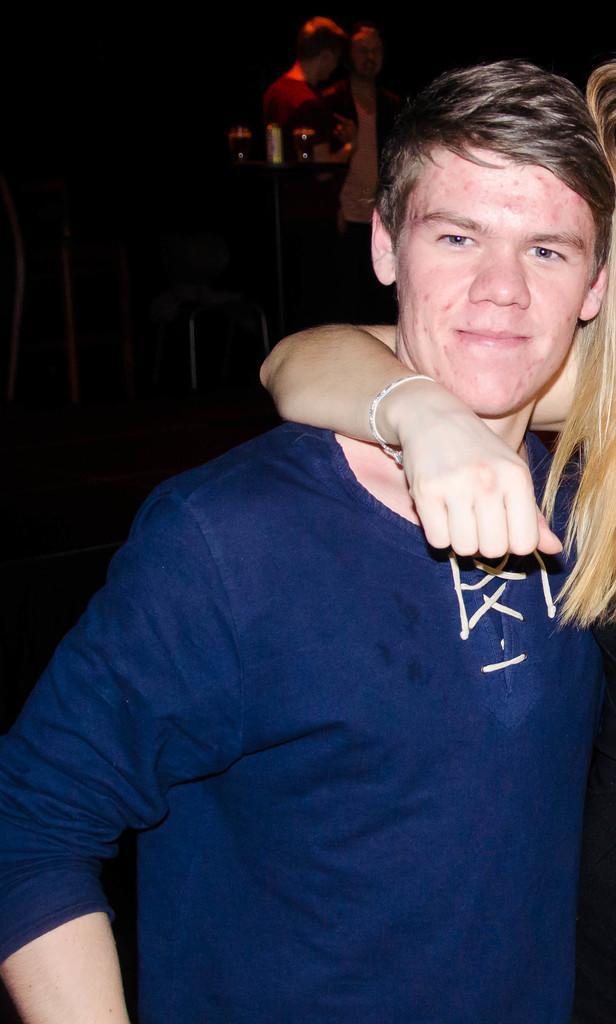How would you summarize this image in a sentence or two? In this image we can see persons standing on the floor. In the background we can see glass tumblers on the side table and chairs. 